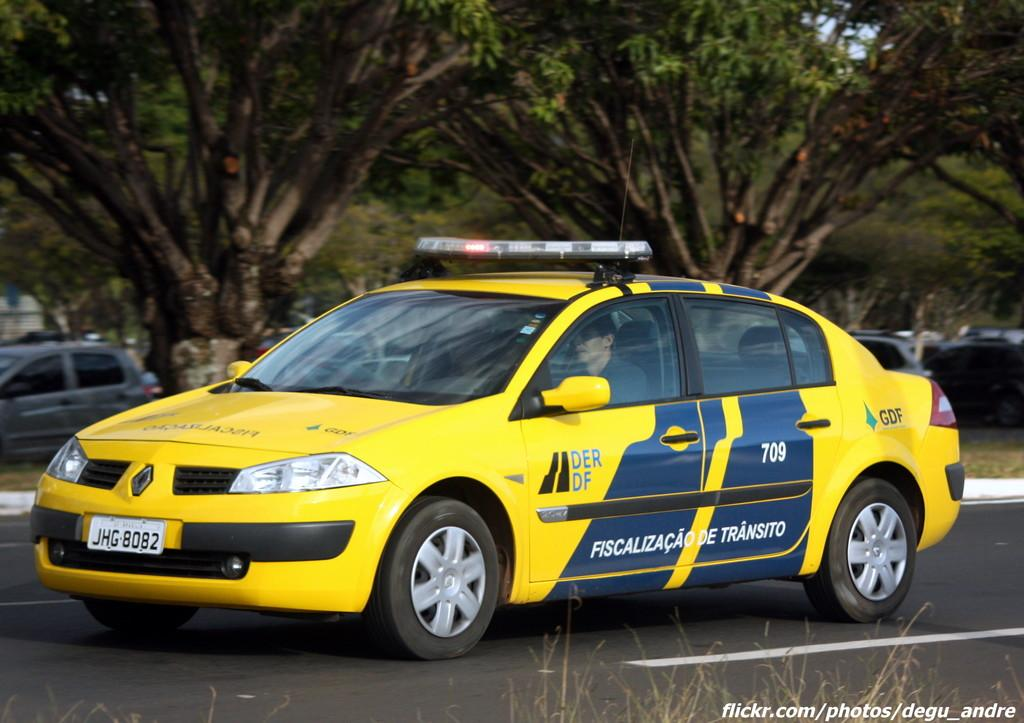<image>
Give a short and clear explanation of the subsequent image. A car with lights on the top has the license plate number JHG 8082. 